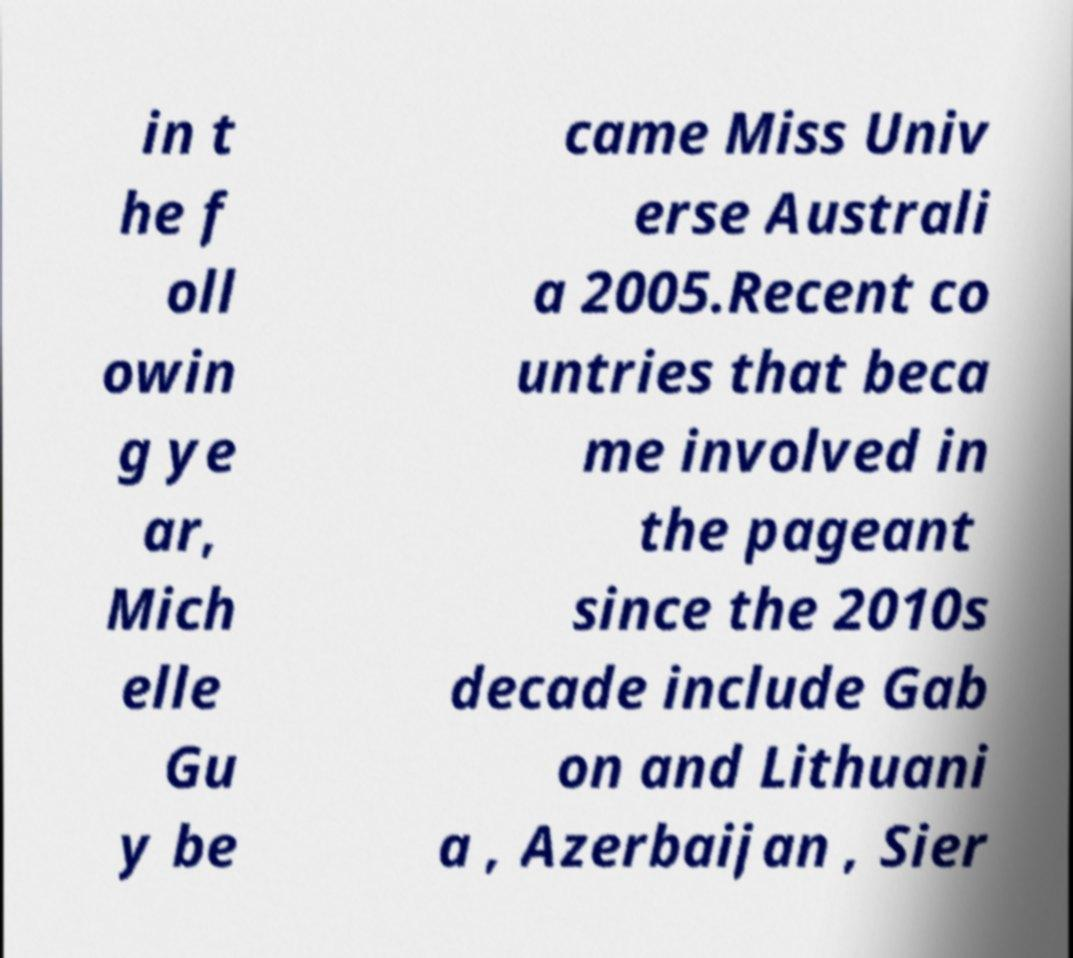What messages or text are displayed in this image? I need them in a readable, typed format. in t he f oll owin g ye ar, Mich elle Gu y be came Miss Univ erse Australi a 2005.Recent co untries that beca me involved in the pageant since the 2010s decade include Gab on and Lithuani a , Azerbaijan , Sier 